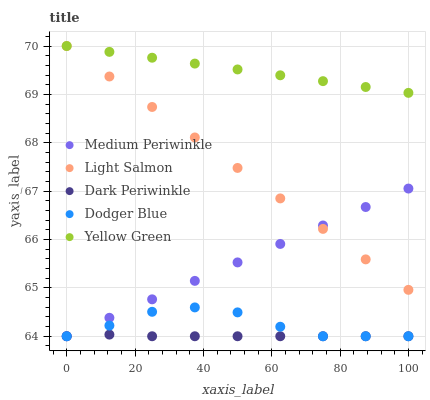Does Dark Periwinkle have the minimum area under the curve?
Answer yes or no. Yes. Does Yellow Green have the maximum area under the curve?
Answer yes or no. Yes. Does Light Salmon have the minimum area under the curve?
Answer yes or no. No. Does Light Salmon have the maximum area under the curve?
Answer yes or no. No. Is Medium Periwinkle the smoothest?
Answer yes or no. Yes. Is Dodger Blue the roughest?
Answer yes or no. Yes. Is Light Salmon the smoothest?
Answer yes or no. No. Is Light Salmon the roughest?
Answer yes or no. No. Does Dodger Blue have the lowest value?
Answer yes or no. Yes. Does Light Salmon have the lowest value?
Answer yes or no. No. Does Yellow Green have the highest value?
Answer yes or no. Yes. Does Medium Periwinkle have the highest value?
Answer yes or no. No. Is Dark Periwinkle less than Light Salmon?
Answer yes or no. Yes. Is Yellow Green greater than Medium Periwinkle?
Answer yes or no. Yes. Does Light Salmon intersect Yellow Green?
Answer yes or no. Yes. Is Light Salmon less than Yellow Green?
Answer yes or no. No. Is Light Salmon greater than Yellow Green?
Answer yes or no. No. Does Dark Periwinkle intersect Light Salmon?
Answer yes or no. No. 